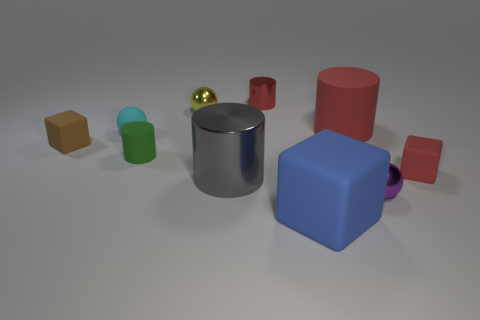Subtract 1 cylinders. How many cylinders are left? 3 Subtract all brown cylinders. Subtract all purple balls. How many cylinders are left? 4 Subtract all cylinders. How many objects are left? 6 Subtract 0 brown balls. How many objects are left? 10 Subtract all big green cylinders. Subtract all tiny cyan matte objects. How many objects are left? 9 Add 3 small cyan matte things. How many small cyan matte things are left? 4 Add 5 small gray shiny spheres. How many small gray shiny spheres exist? 5 